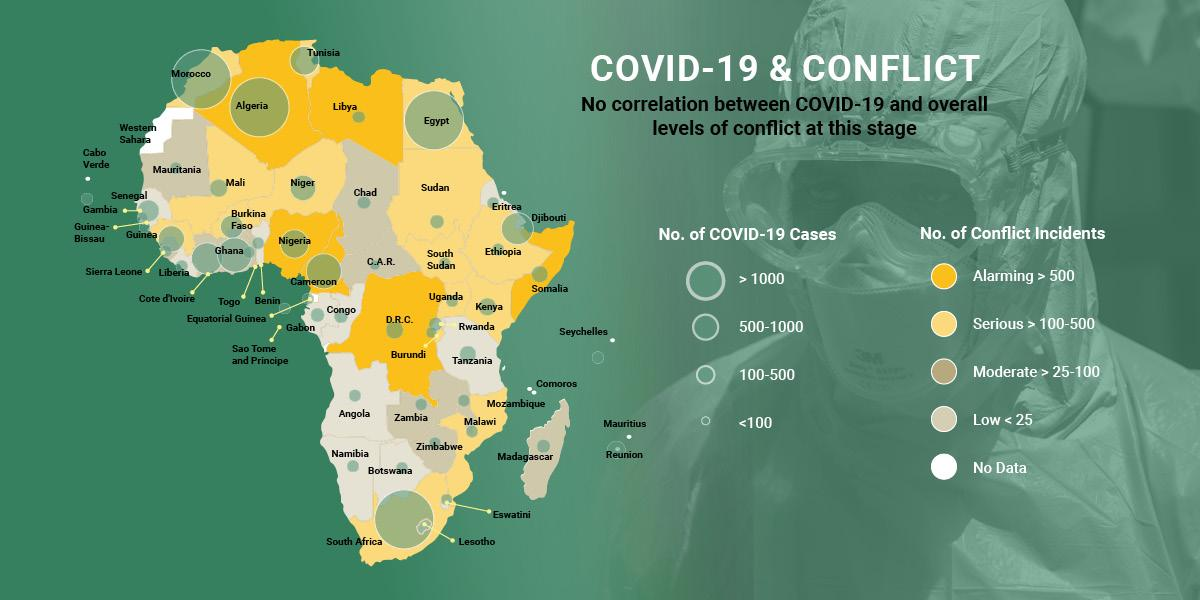Highlight a few significant elements in this photo. The number of COVID-19 cases in Tunisia is between 500 and 1,000. There are currently 4 countries with confirmed cases of Covid-19 greater than 1000. There are currently between 100 and 500 confirmed cases of COVID-19 in the Democratic Republic of the Congo. There are approximately 500 to 1000 confirmed cases of COVID-19 in Niger. The number of COVID-19 cases in Mali is estimated to be between 100 and 500. 